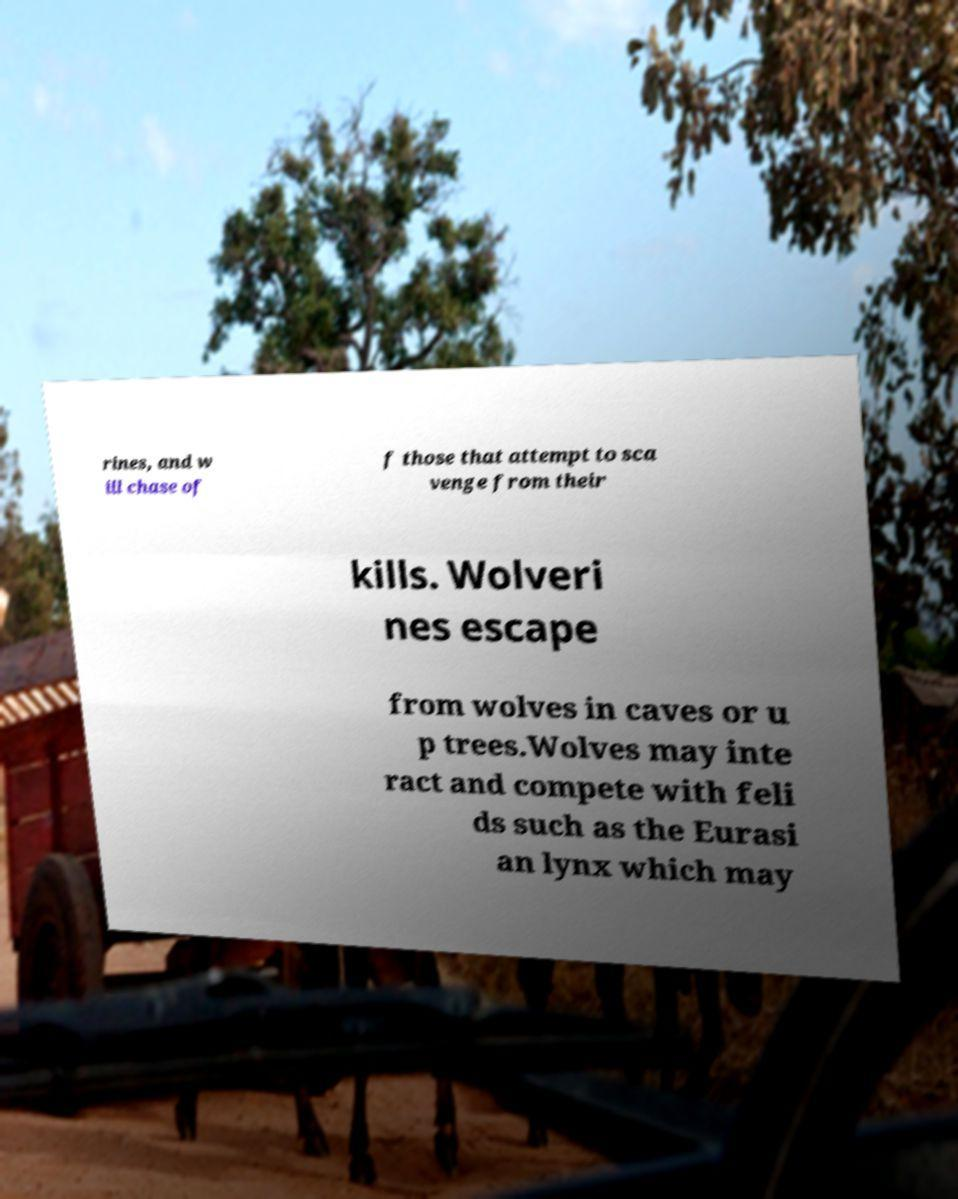What messages or text are displayed in this image? I need them in a readable, typed format. rines, and w ill chase of f those that attempt to sca venge from their kills. Wolveri nes escape from wolves in caves or u p trees.Wolves may inte ract and compete with feli ds such as the Eurasi an lynx which may 